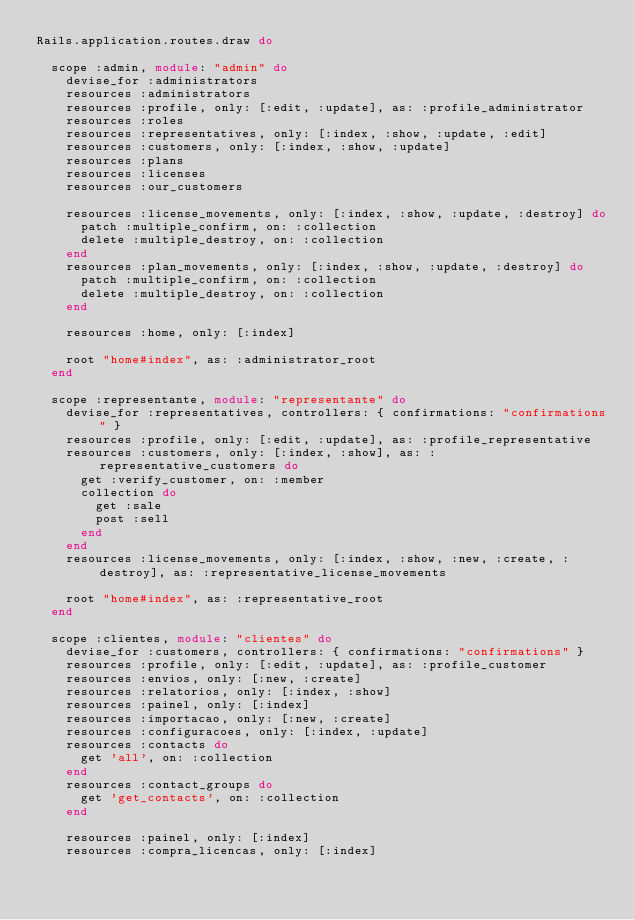Convert code to text. <code><loc_0><loc_0><loc_500><loc_500><_Ruby_>Rails.application.routes.draw do

  scope :admin, module: "admin" do
    devise_for :administrators
    resources :administrators
    resources :profile, only: [:edit, :update], as: :profile_administrator
    resources :roles
    resources :representatives, only: [:index, :show, :update, :edit]
    resources :customers, only: [:index, :show, :update]
    resources :plans
    resources :licenses
    resources :our_customers

    resources :license_movements, only: [:index, :show, :update, :destroy] do
      patch :multiple_confirm, on: :collection
      delete :multiple_destroy, on: :collection
    end
    resources :plan_movements, only: [:index, :show, :update, :destroy] do
      patch :multiple_confirm, on: :collection
      delete :multiple_destroy, on: :collection
    end

    resources :home, only: [:index]

    root "home#index", as: :administrator_root
  end

  scope :representante, module: "representante" do
    devise_for :representatives, controllers: { confirmations: "confirmations" }
    resources :profile, only: [:edit, :update], as: :profile_representative
    resources :customers, only: [:index, :show], as: :representative_customers do
      get :verify_customer, on: :member
      collection do
        get :sale
        post :sell
      end
    end
    resources :license_movements, only: [:index, :show, :new, :create, :destroy], as: :representative_license_movements

    root "home#index", as: :representative_root
  end

  scope :clientes, module: "clientes" do
    devise_for :customers, controllers: { confirmations: "confirmations" }
    resources :profile, only: [:edit, :update], as: :profile_customer
    resources :envios, only: [:new, :create]
    resources :relatorios, only: [:index, :show]
    resources :painel, only: [:index]
    resources :importacao, only: [:new, :create]
    resources :configuracoes, only: [:index, :update]
    resources :contacts do
      get 'all', on: :collection
    end
    resources :contact_groups do
      get 'get_contacts', on: :collection
    end

    resources :painel, only: [:index]
    resources :compra_licencas, only: [:index]
</code> 